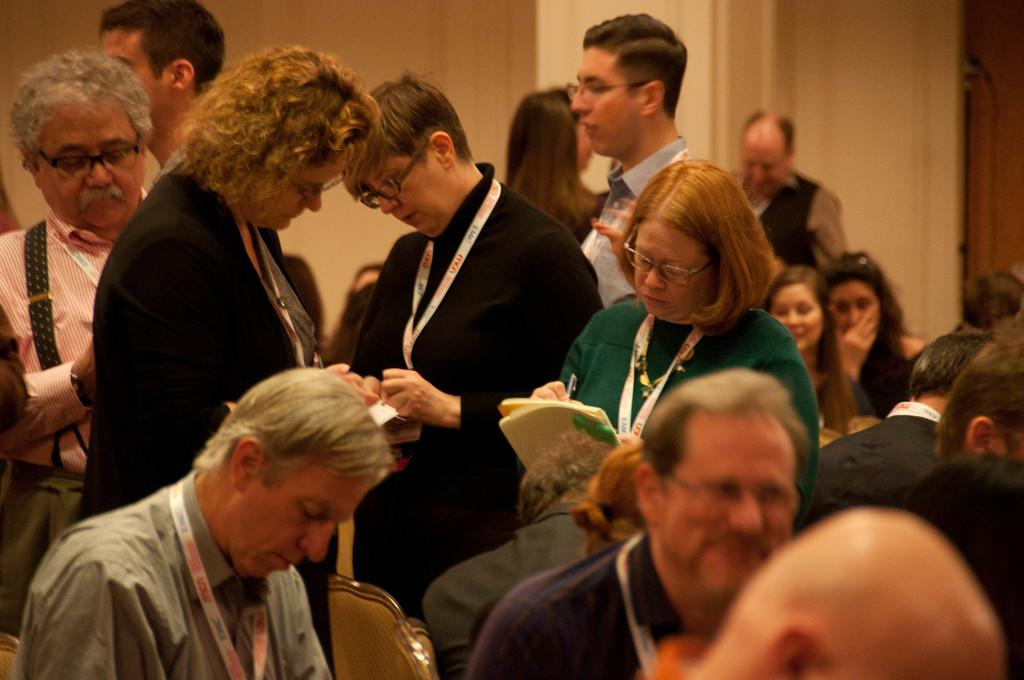How many people are in the image? There is a group of people in the image, but the exact number is not specified. What are some people doing in the image? Some people are sitting in the image. Can you identify any accessories or items that some people are wearing? Some people are wearing ID cards in the image. What can be seen in the background of the image? There is a wall in the background of the image. What type of plastic is being used to measure the height of the company in the image? There is no plastic or measurement of a company's height present in the image. 